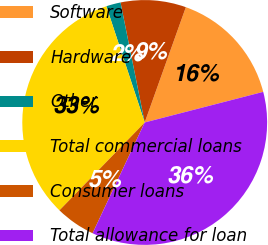<chart> <loc_0><loc_0><loc_500><loc_500><pie_chart><fcel>Software<fcel>Hardware<fcel>Other<fcel>Total commercial loans<fcel>Consumer loans<fcel>Total allowance for loan<nl><fcel>15.52%<fcel>8.62%<fcel>1.91%<fcel>32.66%<fcel>5.26%<fcel>36.02%<nl></chart> 